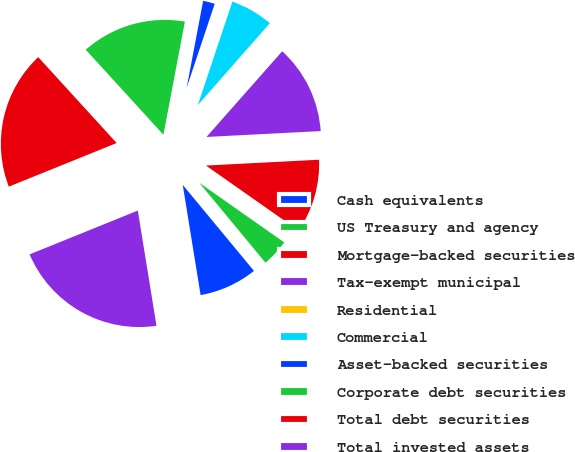Convert chart. <chart><loc_0><loc_0><loc_500><loc_500><pie_chart><fcel>Cash equivalents<fcel>US Treasury and agency<fcel>Mortgage-backed securities<fcel>Tax-exempt municipal<fcel>Residential<fcel>Commercial<fcel>Asset-backed securities<fcel>Corporate debt securities<fcel>Total debt securities<fcel>Total invested assets<nl><fcel>8.45%<fcel>4.25%<fcel>10.56%<fcel>12.66%<fcel>0.04%<fcel>6.35%<fcel>2.15%<fcel>14.76%<fcel>19.34%<fcel>21.44%<nl></chart> 